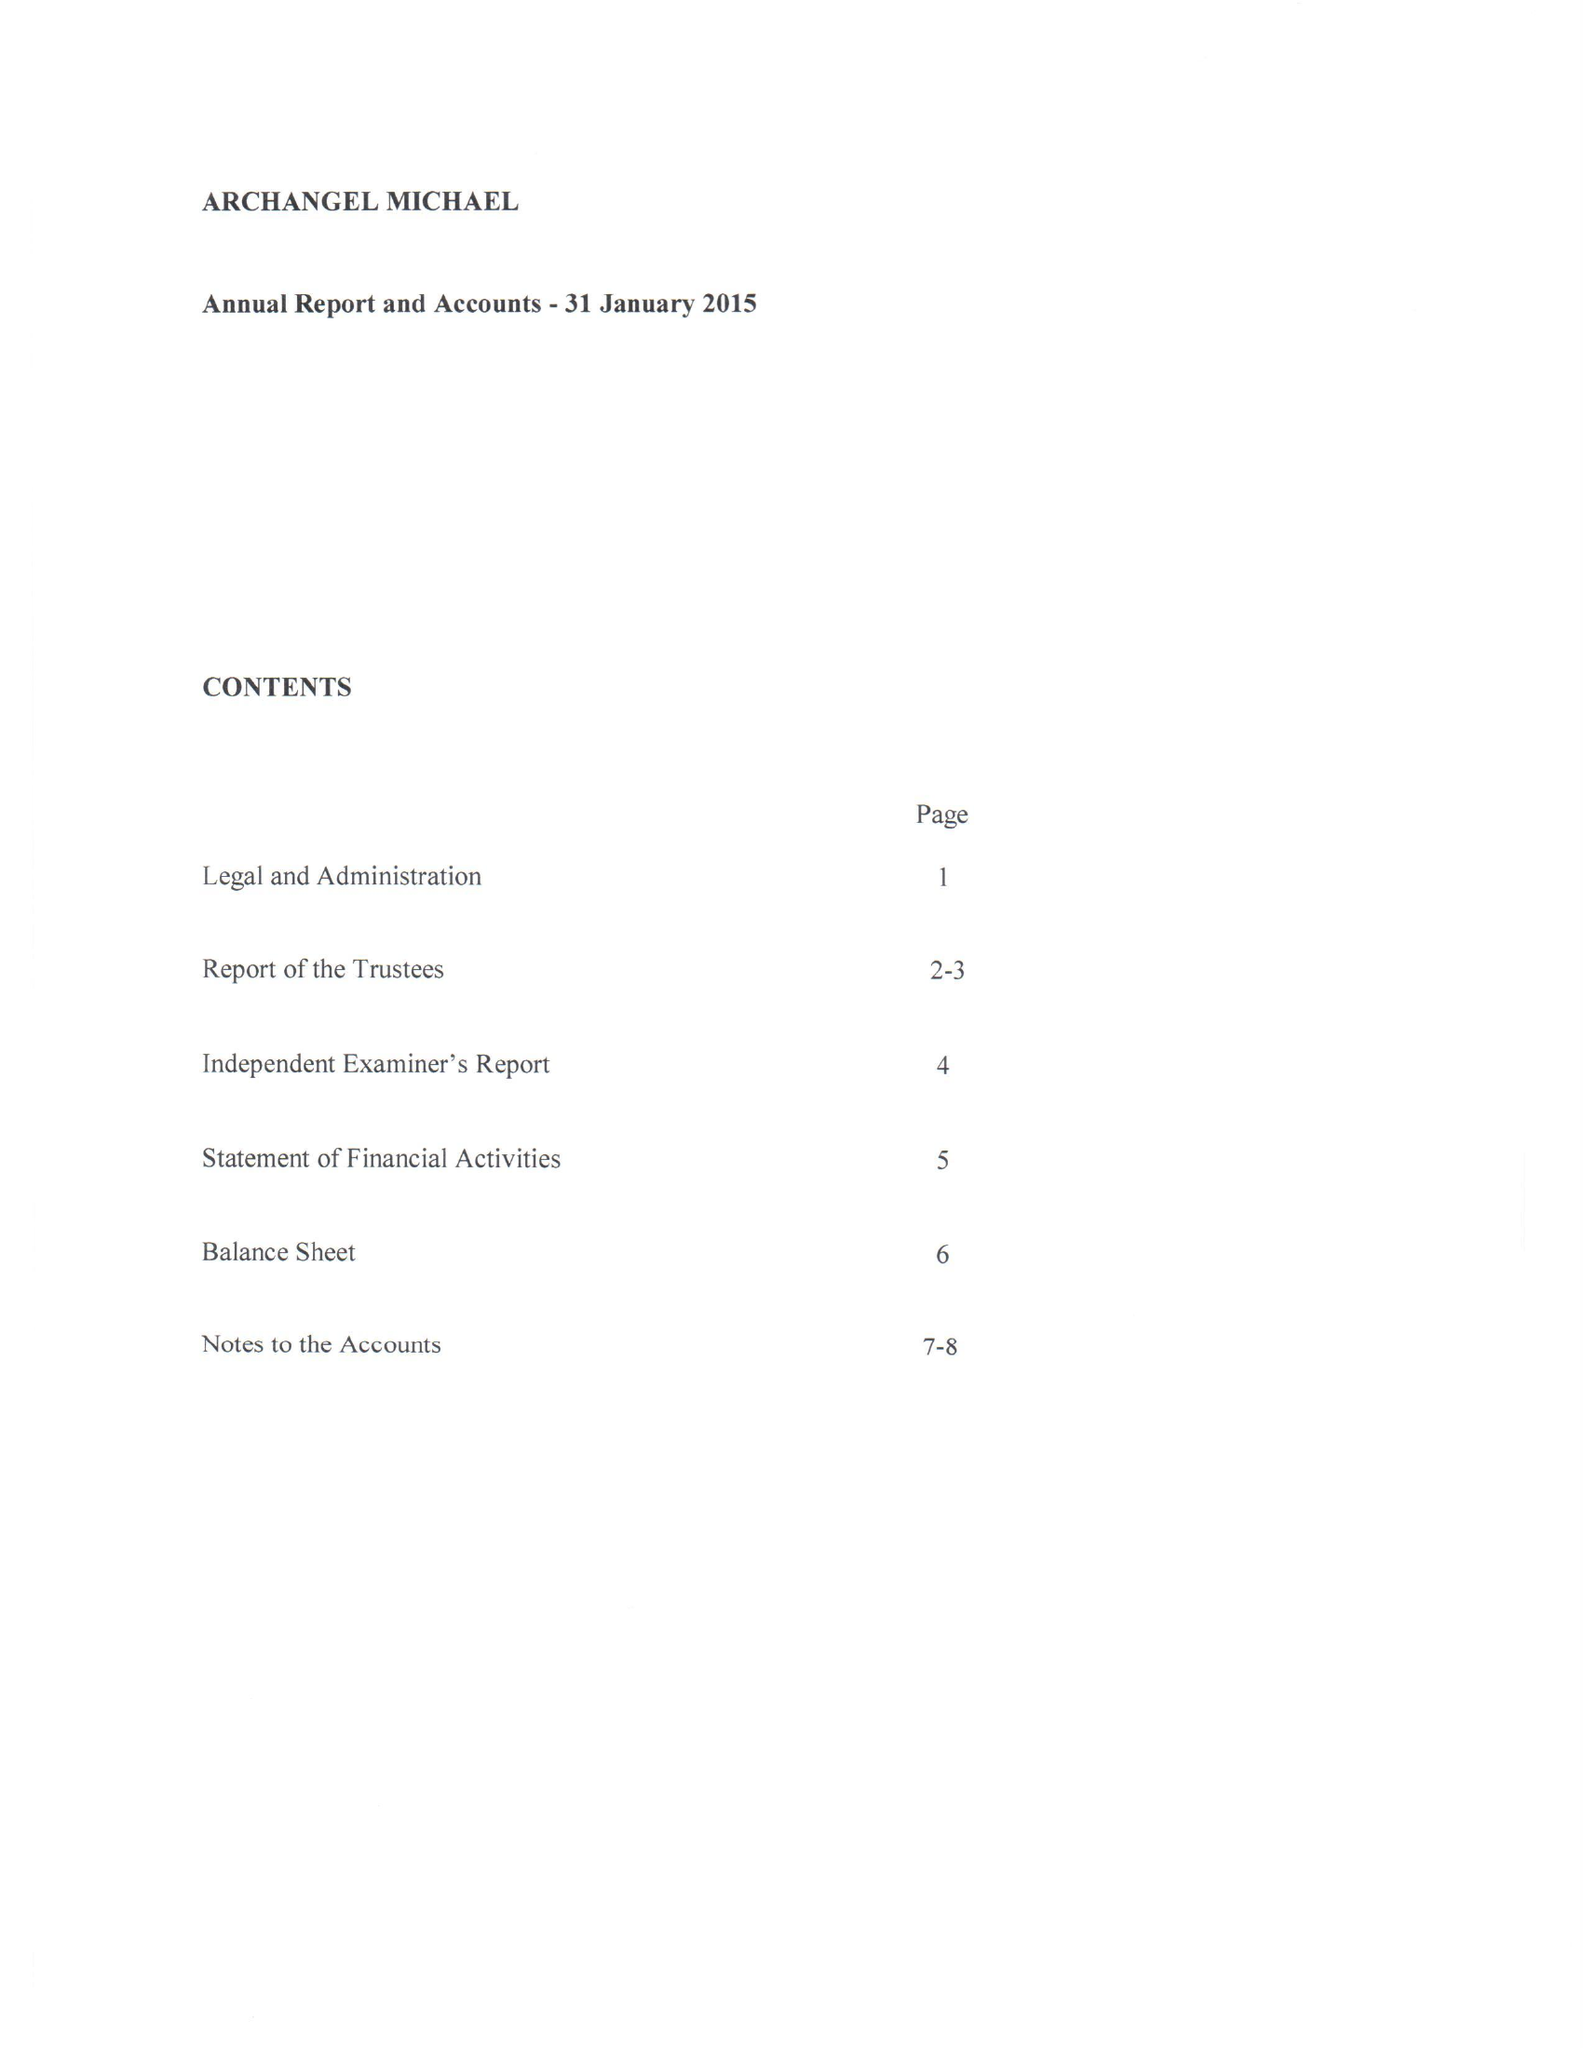What is the value for the spending_annually_in_british_pounds?
Answer the question using a single word or phrase. 25120.00 